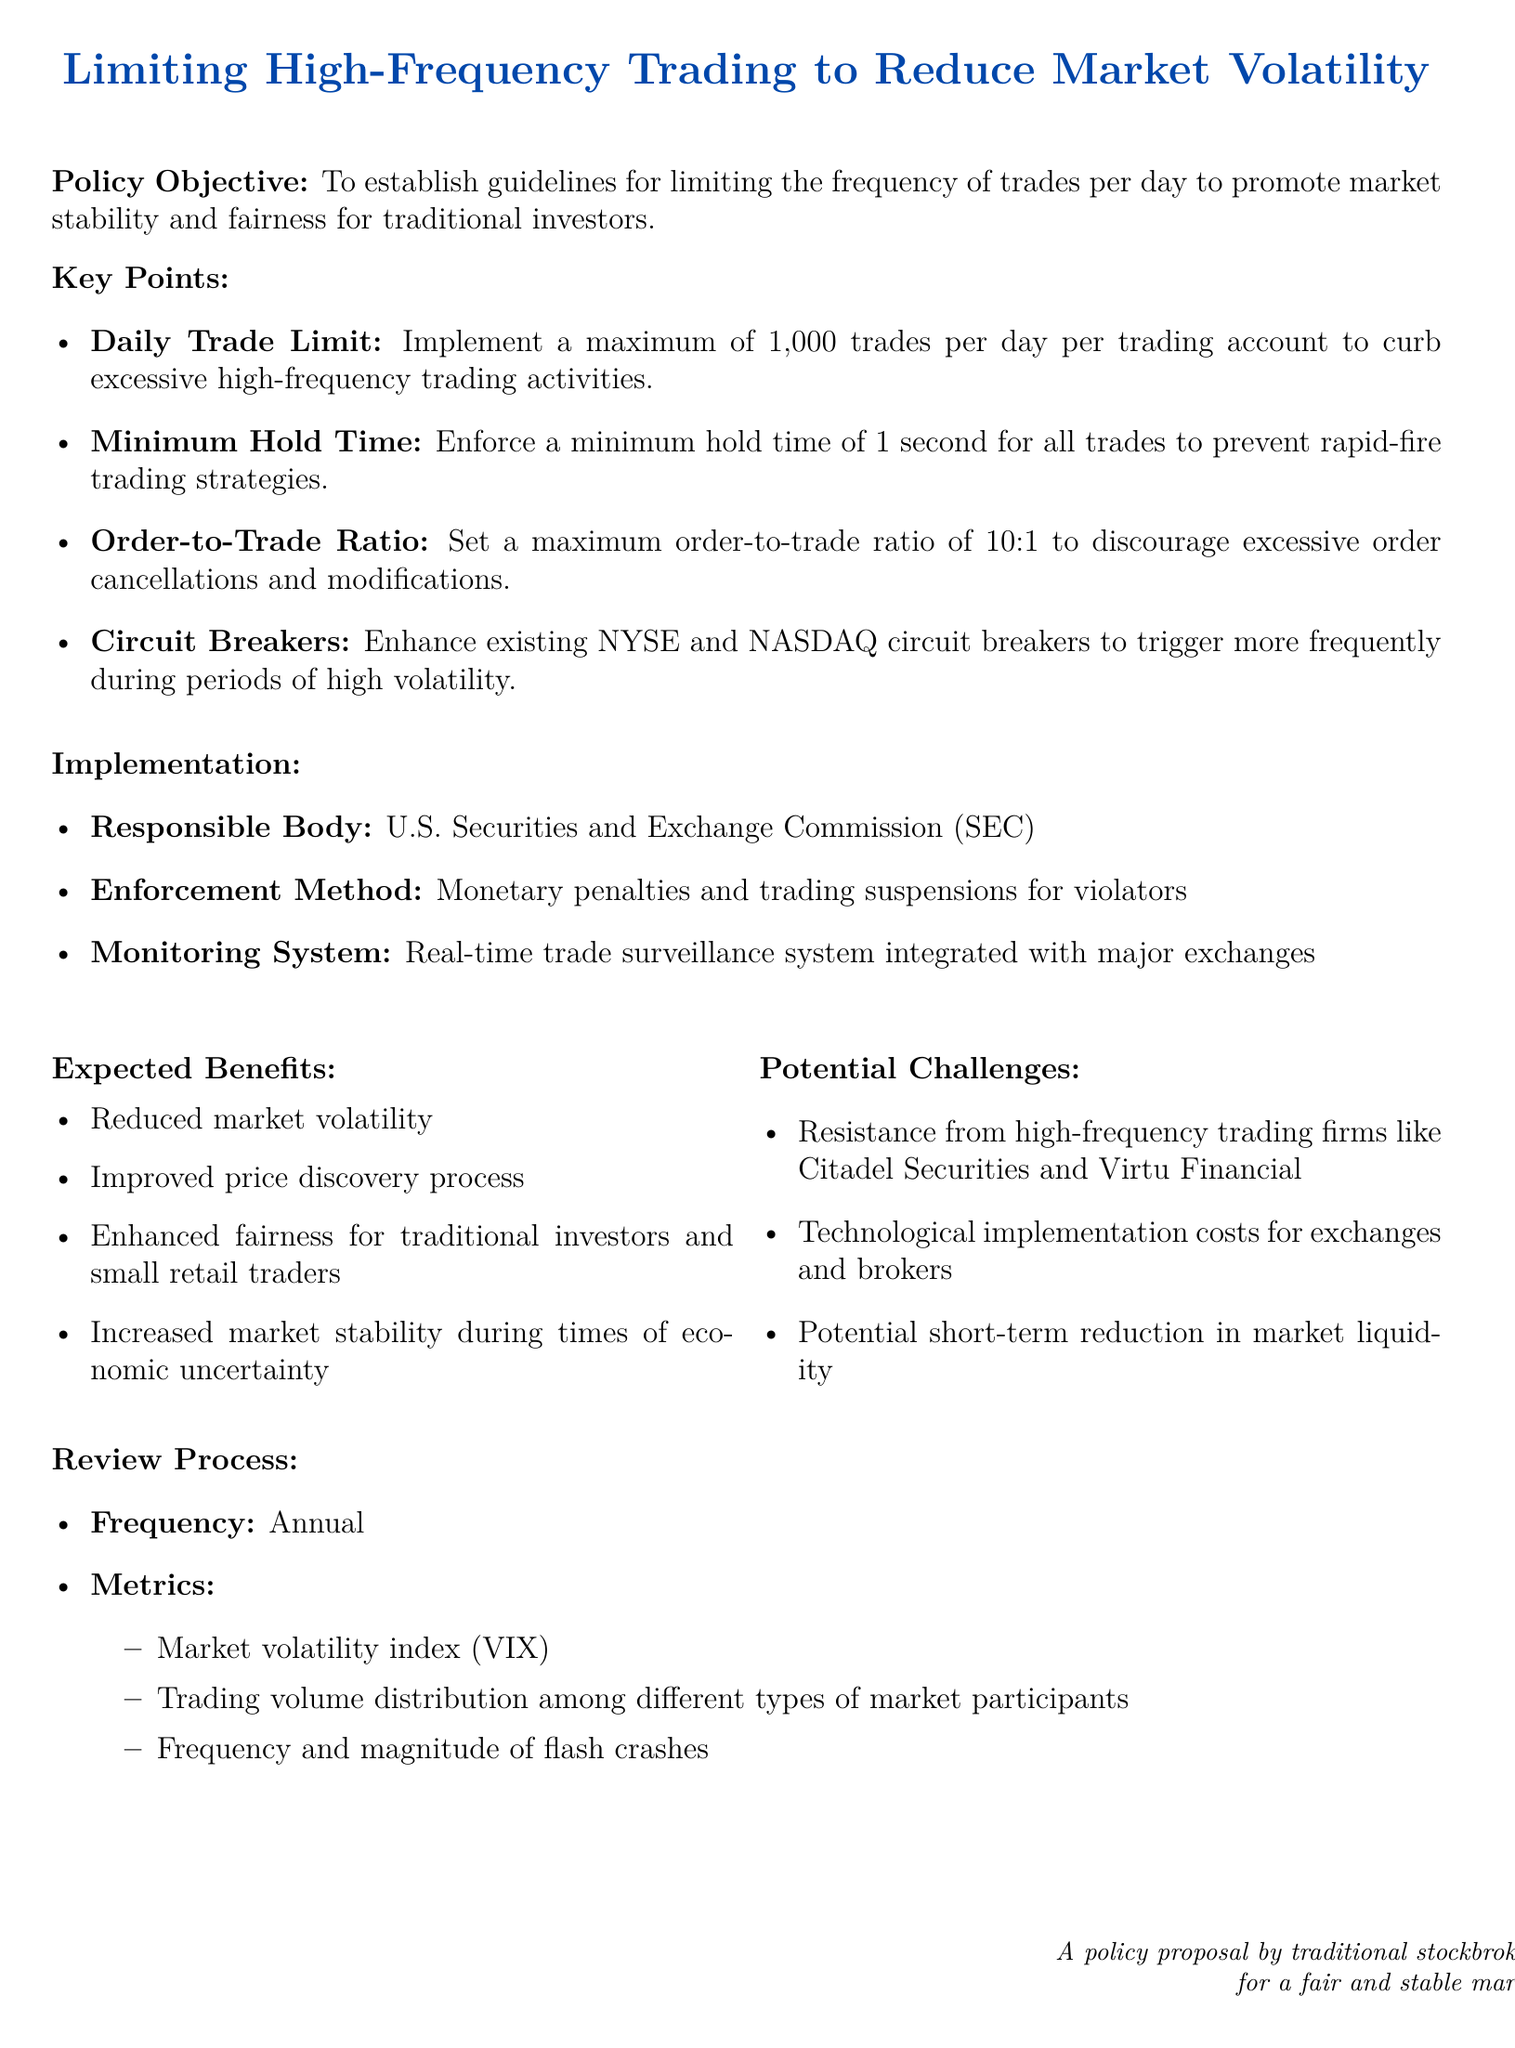What is the policy's objective? The policy's objective is to establish guidelines for limiting the frequency of trades per day to promote market stability and fairness for traditional investors.
Answer: To establish guidelines for limiting the frequency of trades per day to promote market stability and fairness for traditional investors What is the daily trade limit per account? The maximum number of trades allowed per day per trading account is specified in the document.
Answer: 1,000 trades What is the minimum hold time for all trades? The document specifies a minimum hold time required for trades to prevent rapid-fire trading.
Answer: 1 second What is the order-to-trade ratio limit? The document states a maximum order-to-trade ratio to prevent excessive order cancellations.
Answer: 10:1 Who is responsible for enforcing this policy? The responsible body for this policy is mentioned in the document.
Answer: U.S. Securities and Exchange Commission (SEC) What are expected benefits mentioned in the policy? The document lists key benefits of the policy; one example would illustrate the potential impact on market volatility.
Answer: Reduced market volatility What type of firms might resist this policy? The document identifies potential challengers that may oppose the implementation of this policy.
Answer: High-frequency trading firms How often will the policy be reviewed? The frequency of the review process for this policy is stated in the document.
Answer: Annual What metric is used to assess market volatility? The document outlines specific metrics that will be assessed during the review process, including one directly related to market volatility.
Answer: Market volatility index (VIX) 